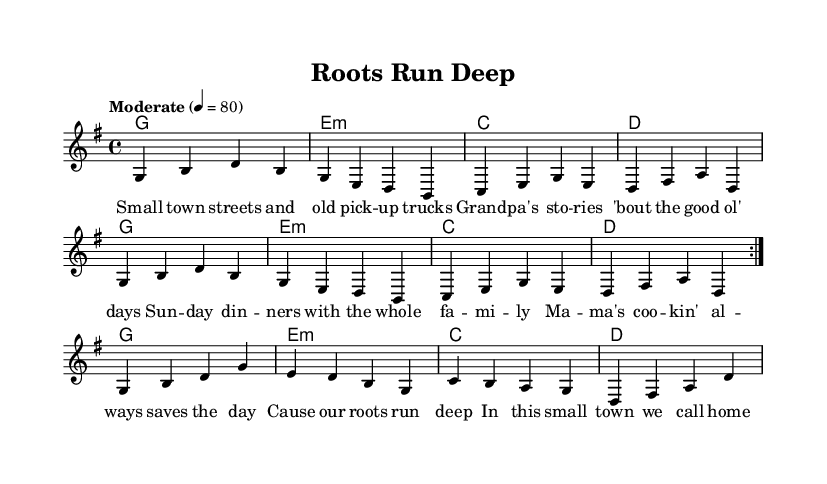What is the key signature of this music? The key signature is indicated at the beginning of the piece. Here, it shows one sharp, indicating it is in G major.
Answer: G major What is the time signature of this music? The time signature is located right after the key signature at the beginning. It is shown as 4/4, meaning there are four beats per measure, and the quarter note gets one beat.
Answer: 4/4 What is the tempo marking for this piece? The tempo marking is placed at the start of the sheet music, specifying "Moderate" with a metronome marking of 80, indicating the speed of the performance.
Answer: Moderate 80 How many times is the melody repeated in the first section? The melody has a repeat sign indicated at the beginning, showing that the first section is to be played twice before moving on.
Answer: 2 What is the theme of the lyrics in this song? The lyrics encompass elements of small-town life, family gatherings, and values, emphasized in the verses and chorus throughout the sheet music.
Answer: Family values What chords are used in the chorus? The chords are listed in a separate part and match the lyrics in the chorus. A quick look reveals the chords G, E minor, C, and D are used, consistent with country music harmonies.
Answer: G, E minor, C, D What is the overall structure of this song? By analyzing the organization of the lyrics and patterns, it follows a classic verse-chorus format, typical of country music storytelling songs.
Answer: Verse-Chorus structure 